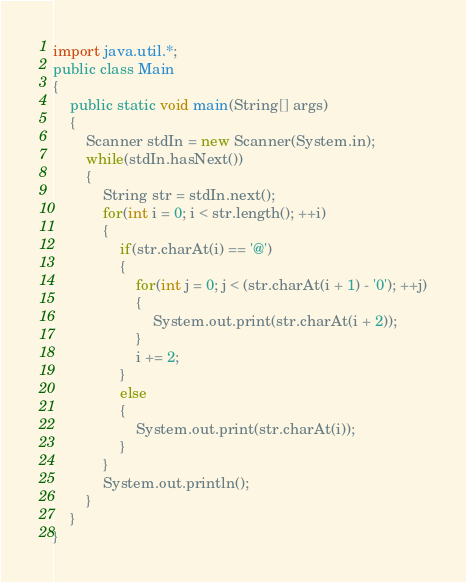Convert code to text. <code><loc_0><loc_0><loc_500><loc_500><_Java_>import java.util.*;
public class Main 
{
	public static void main(String[] args) 
	{
		Scanner stdIn = new Scanner(System.in);
		while(stdIn.hasNext())
		{
			String str = stdIn.next();
			for(int i = 0; i < str.length(); ++i)
			{
				if(str.charAt(i) == '@')
				{
					for(int j = 0; j < (str.charAt(i + 1) - '0'); ++j)
					{
						System.out.print(str.charAt(i + 2));
					}
					i += 2;
				}
				else
				{
					System.out.print(str.charAt(i));
				}
			}
			System.out.println();
		}
	}
}</code> 